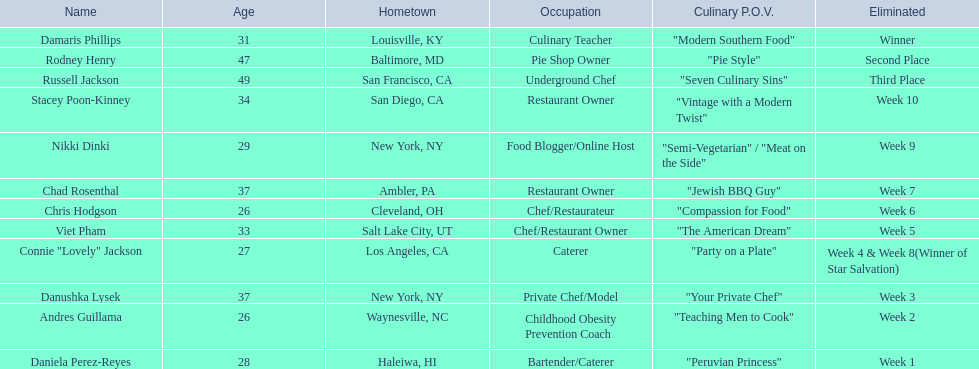Who are the stars on food network? Damaris Phillips, Rodney Henry, Russell Jackson, Stacey Poon-Kinney, Nikki Dinki, Chad Rosenthal, Chris Hodgson, Viet Pham, Connie "Lovely" Jackson, Danushka Lysek, Andres Guillama, Daniela Perez-Reyes. When was nikki dinki eliminated? Week 9. When was viet pham eliminated? Week 5. Which elimination occurred earlier? Week 5. Who was the contestant eliminated during the fifth week? Viet Pham. 